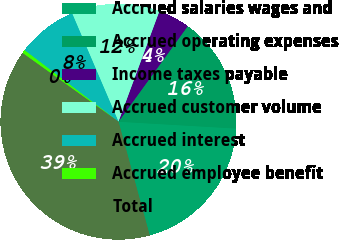Convert chart. <chart><loc_0><loc_0><loc_500><loc_500><pie_chart><fcel>Accrued salaries wages and<fcel>Accrued operating expenses<fcel>Income taxes payable<fcel>Accrued customer volume<fcel>Accrued interest<fcel>Accrued employee benefit<fcel>Total<nl><fcel>19.81%<fcel>15.94%<fcel>4.34%<fcel>12.08%<fcel>8.21%<fcel>0.47%<fcel>39.15%<nl></chart> 